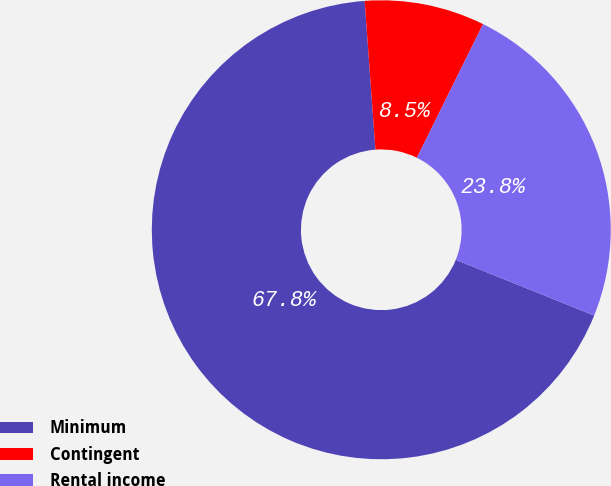<chart> <loc_0><loc_0><loc_500><loc_500><pie_chart><fcel>Minimum<fcel>Contingent<fcel>Rental income<nl><fcel>67.75%<fcel>8.47%<fcel>23.78%<nl></chart> 